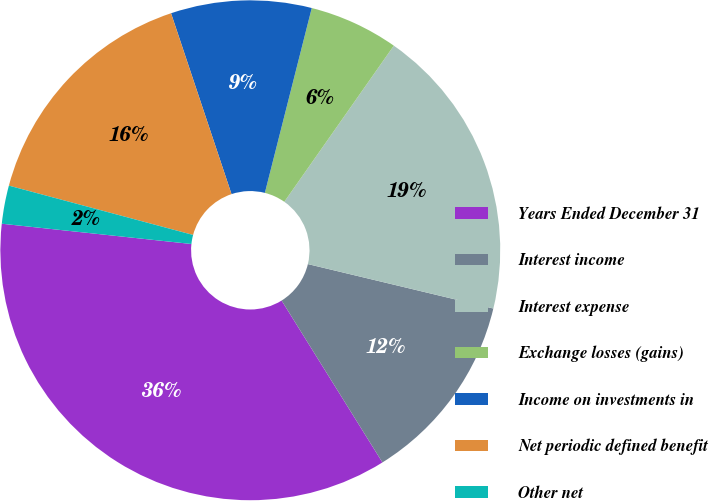Convert chart to OTSL. <chart><loc_0><loc_0><loc_500><loc_500><pie_chart><fcel>Years Ended December 31<fcel>Interest income<fcel>Interest expense<fcel>Exchange losses (gains)<fcel>Income on investments in<fcel>Net periodic defined benefit<fcel>Other net<nl><fcel>35.56%<fcel>12.39%<fcel>19.01%<fcel>5.78%<fcel>9.09%<fcel>15.7%<fcel>2.47%<nl></chart> 